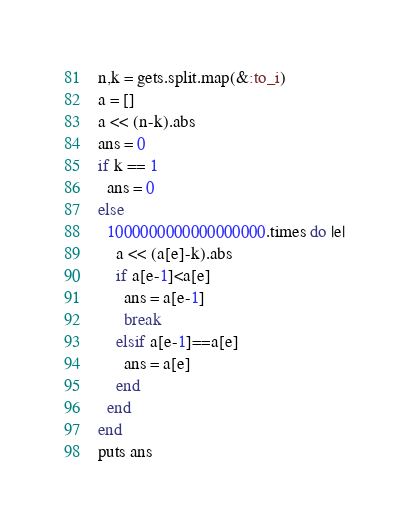Convert code to text. <code><loc_0><loc_0><loc_500><loc_500><_Ruby_>n,k = gets.split.map(&:to_i)
a = []
a << (n-k).abs
ans = 0
if k == 1
  ans = 0
else
  1000000000000000000.times do |e|
    a << (a[e]-k).abs
    if a[e-1]<a[e]
      ans = a[e-1]
      break
    elsif a[e-1]==a[e]
      ans = a[e]
    end
  end
end
puts ans
</code> 